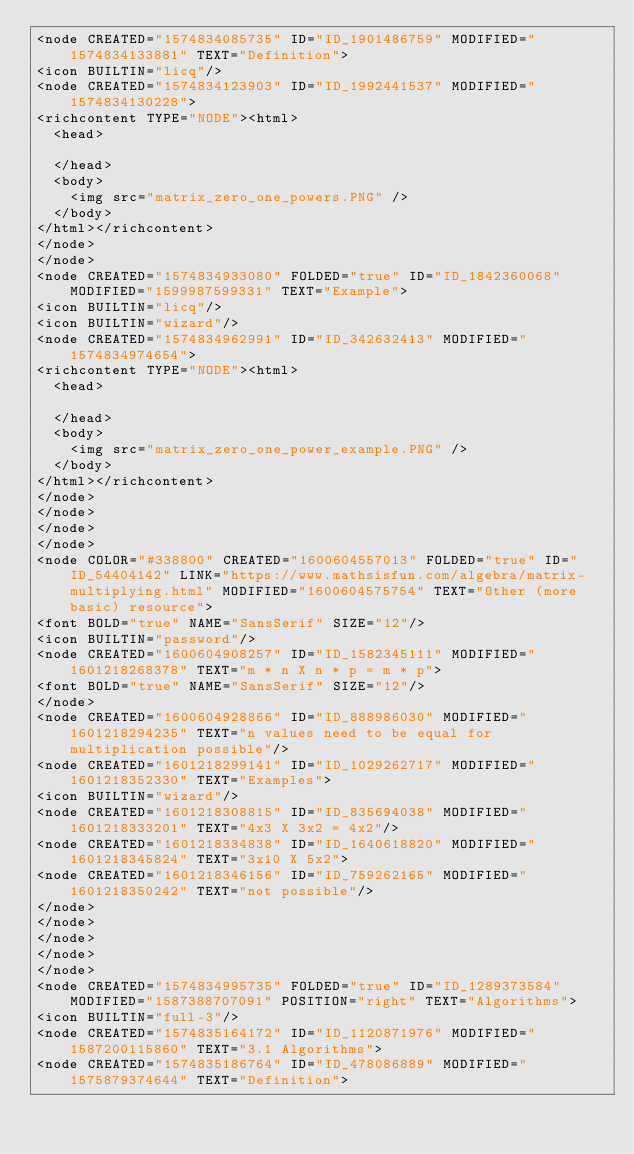<code> <loc_0><loc_0><loc_500><loc_500><_ObjectiveC_><node CREATED="1574834085735" ID="ID_1901486759" MODIFIED="1574834133881" TEXT="Definition">
<icon BUILTIN="licq"/>
<node CREATED="1574834123903" ID="ID_1992441537" MODIFIED="1574834130228">
<richcontent TYPE="NODE"><html>
  <head>
    
  </head>
  <body>
    <img src="matrix_zero_one_powers.PNG" />
  </body>
</html></richcontent>
</node>
</node>
<node CREATED="1574834933080" FOLDED="true" ID="ID_1842360068" MODIFIED="1599987599331" TEXT="Example">
<icon BUILTIN="licq"/>
<icon BUILTIN="wizard"/>
<node CREATED="1574834962991" ID="ID_342632413" MODIFIED="1574834974654">
<richcontent TYPE="NODE"><html>
  <head>
    
  </head>
  <body>
    <img src="matrix_zero_one_power_example.PNG" />
  </body>
</html></richcontent>
</node>
</node>
</node>
</node>
<node COLOR="#338800" CREATED="1600604557013" FOLDED="true" ID="ID_54404142" LINK="https://www.mathsisfun.com/algebra/matrix-multiplying.html" MODIFIED="1600604575754" TEXT="Other (more basic) resource">
<font BOLD="true" NAME="SansSerif" SIZE="12"/>
<icon BUILTIN="password"/>
<node CREATED="1600604908257" ID="ID_1582345111" MODIFIED="1601218268378" TEXT="m * n X n * p = m * p">
<font BOLD="true" NAME="SansSerif" SIZE="12"/>
</node>
<node CREATED="1600604928866" ID="ID_888986030" MODIFIED="1601218294235" TEXT="n values need to be equal for multiplication possible"/>
<node CREATED="1601218299141" ID="ID_1029262717" MODIFIED="1601218352330" TEXT="Examples">
<icon BUILTIN="wizard"/>
<node CREATED="1601218308815" ID="ID_835694038" MODIFIED="1601218333201" TEXT="4x3 X 3x2 = 4x2"/>
<node CREATED="1601218334838" ID="ID_1640618820" MODIFIED="1601218345824" TEXT="3x10 X 5x2">
<node CREATED="1601218346156" ID="ID_759262165" MODIFIED="1601218350242" TEXT="not possible"/>
</node>
</node>
</node>
</node>
</node>
<node CREATED="1574834995735" FOLDED="true" ID="ID_1289373584" MODIFIED="1587388707091" POSITION="right" TEXT="Algorithms">
<icon BUILTIN="full-3"/>
<node CREATED="1574835164172" ID="ID_1120871976" MODIFIED="1587200115860" TEXT="3.1 Algorithms">
<node CREATED="1574835186764" ID="ID_478086889" MODIFIED="1575879374644" TEXT="Definition"></code> 